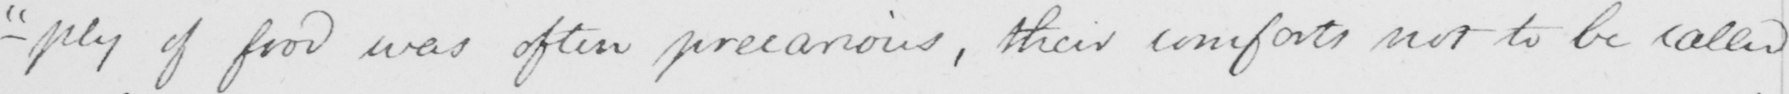What does this handwritten line say? -"ply "of food was often precarious, their comforts not to be called 